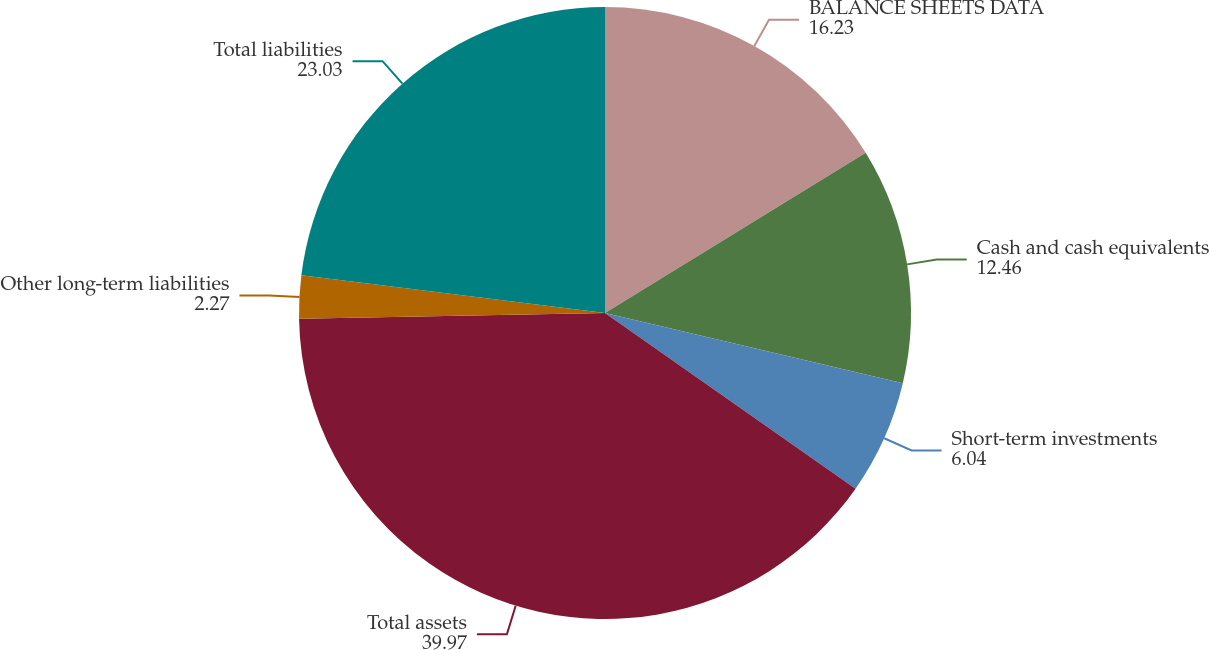Convert chart to OTSL. <chart><loc_0><loc_0><loc_500><loc_500><pie_chart><fcel>BALANCE SHEETS DATA<fcel>Cash and cash equivalents<fcel>Short-term investments<fcel>Total assets<fcel>Other long-term liabilities<fcel>Total liabilities<nl><fcel>16.23%<fcel>12.46%<fcel>6.04%<fcel>39.97%<fcel>2.27%<fcel>23.03%<nl></chart> 